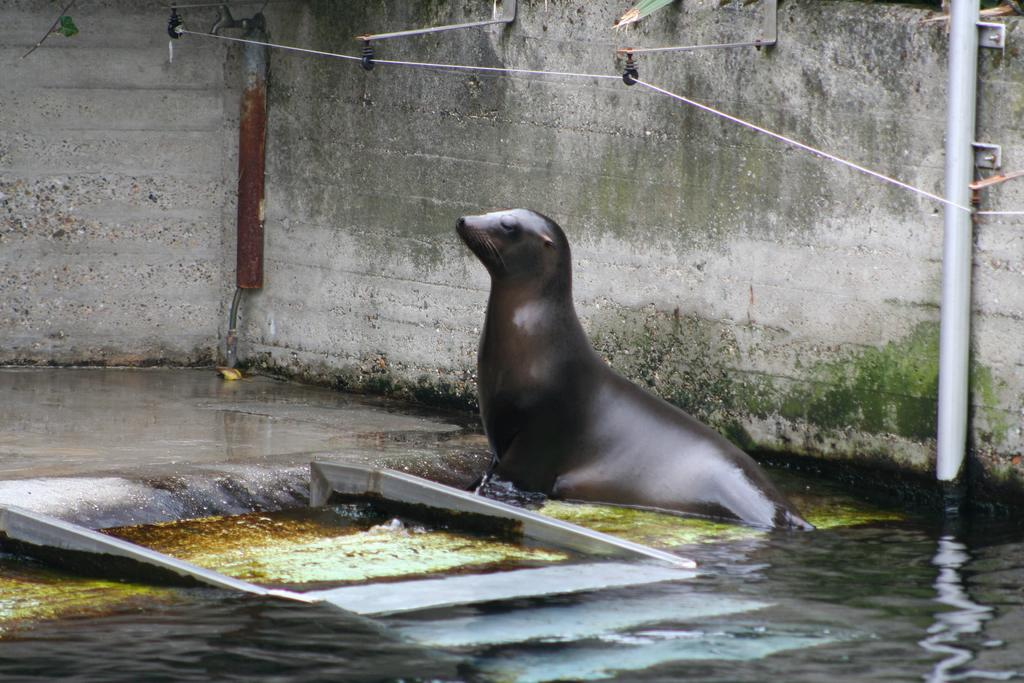What type of animal is in the water in the image? There is a sea lion in the water in the image. What else can be seen in the image besides the sea lion? Pipes and metal rods on a wall are visible in the image. Can you describe the pipes in the image? The pipes are visible in the image, but their specific characteristics are not mentioned in the provided facts. What material are the metal rods made of? The metal rods are made of metal, as indicated by the fact that they are described as "metal rods." What type of toothbrush is the sea lion using in the image? There is no toothbrush present in the image; it features a sea lion in the water and other objects such as pipes and metal rods on a wall. 